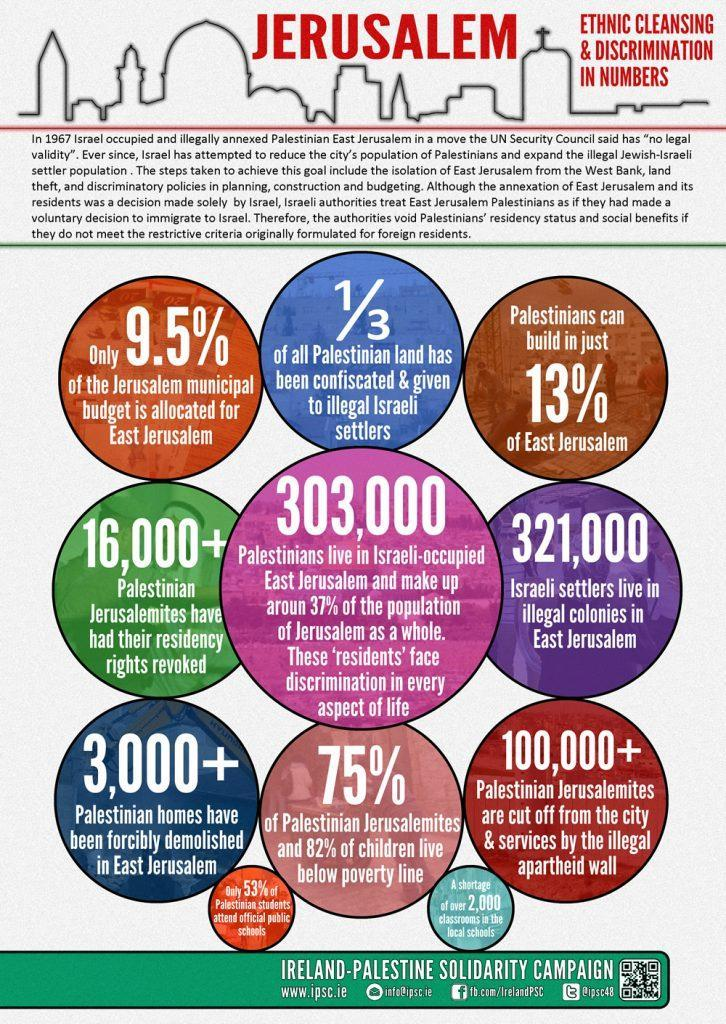What percentage of Palestinian Jerusalemites live below the poverty line?
Answer the question with a short phrase. 75% What is the population of Palestinian Jerusalemites who had their residency rights revoked? 16,000+ What is the number of Palestinian homes which have been forcibly demolished in East Jerusalem? 3,000+ What percentage of Jerusalem population is occupied by the Palestinians? 37% What percent of Palestinian students do not attend official public schools? 47% How many Israeli settlers live in illegal colonies in East Jerusalem? 321,000 